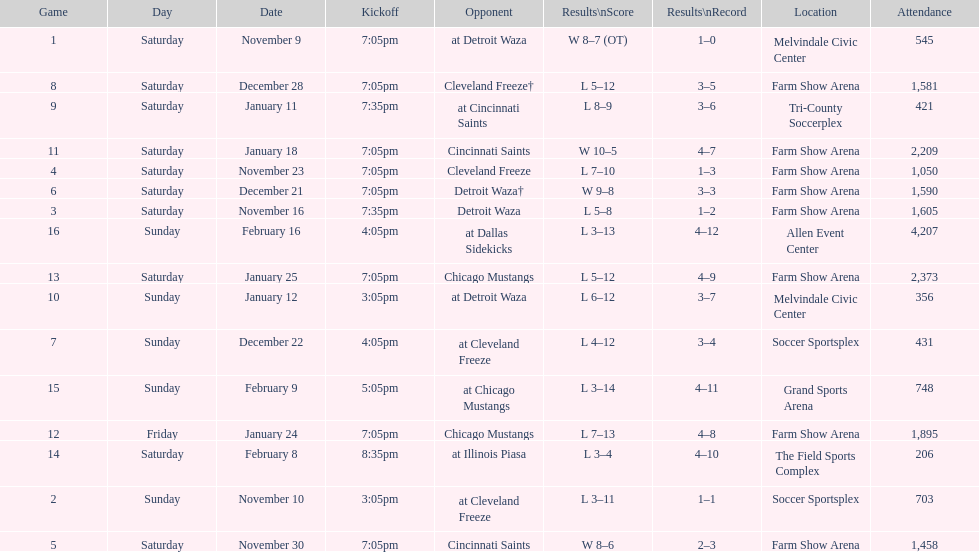Who was the first opponent on this list? Detroit Waza. Could you parse the entire table as a dict? {'header': ['Game', 'Day', 'Date', 'Kickoff', 'Opponent', 'Results\\nScore', 'Results\\nRecord', 'Location', 'Attendance'], 'rows': [['1', 'Saturday', 'November 9', '7:05pm', 'at Detroit Waza', 'W 8–7 (OT)', '1–0', 'Melvindale Civic Center', '545'], ['8', 'Saturday', 'December 28', '7:05pm', 'Cleveland Freeze†', 'L 5–12', '3–5', 'Farm Show Arena', '1,581'], ['9', 'Saturday', 'January 11', '7:35pm', 'at Cincinnati Saints', 'L 8–9', '3–6', 'Tri-County Soccerplex', '421'], ['11', 'Saturday', 'January 18', '7:05pm', 'Cincinnati Saints', 'W 10–5', '4–7', 'Farm Show Arena', '2,209'], ['4', 'Saturday', 'November 23', '7:05pm', 'Cleveland Freeze', 'L 7–10', '1–3', 'Farm Show Arena', '1,050'], ['6', 'Saturday', 'December 21', '7:05pm', 'Detroit Waza†', 'W 9–8', '3–3', 'Farm Show Arena', '1,590'], ['3', 'Saturday', 'November 16', '7:35pm', 'Detroit Waza', 'L 5–8', '1–2', 'Farm Show Arena', '1,605'], ['16', 'Sunday', 'February 16', '4:05pm', 'at Dallas Sidekicks', 'L 3–13', '4–12', 'Allen Event Center', '4,207'], ['13', 'Saturday', 'January 25', '7:05pm', 'Chicago Mustangs', 'L 5–12', '4–9', 'Farm Show Arena', '2,373'], ['10', 'Sunday', 'January 12', '3:05pm', 'at Detroit Waza', 'L 6–12', '3–7', 'Melvindale Civic Center', '356'], ['7', 'Sunday', 'December 22', '4:05pm', 'at Cleveland Freeze', 'L 4–12', '3–4', 'Soccer Sportsplex', '431'], ['15', 'Sunday', 'February 9', '5:05pm', 'at Chicago Mustangs', 'L 3–14', '4–11', 'Grand Sports Arena', '748'], ['12', 'Friday', 'January 24', '7:05pm', 'Chicago Mustangs', 'L 7–13', '4–8', 'Farm Show Arena', '1,895'], ['14', 'Saturday', 'February 8', '8:35pm', 'at Illinois Piasa', 'L 3–4', '4–10', 'The Field Sports Complex', '206'], ['2', 'Sunday', 'November 10', '3:05pm', 'at Cleveland Freeze', 'L 3–11', '1–1', 'Soccer Sportsplex', '703'], ['5', 'Saturday', 'November 30', '7:05pm', 'Cincinnati Saints', 'W 8–6', '2–3', 'Farm Show Arena', '1,458']]} 